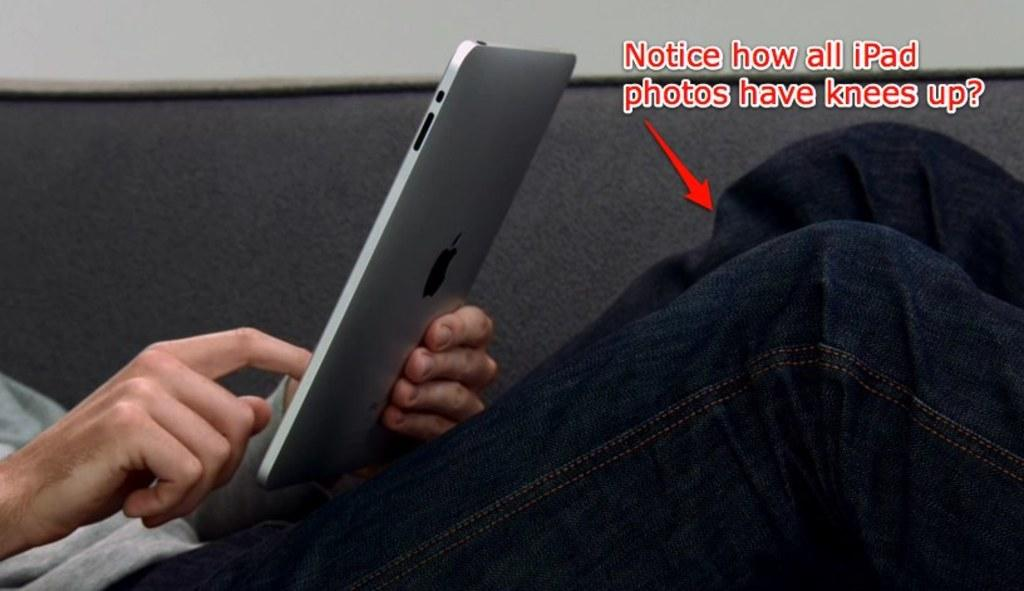What is the person in the image holding? The person is holding an iPad in the image. What can be seen on the iPad? There is writing on the image, which suggests that the person might be reading or writing something on the iPad. What is visible in the background of the image? There is a wall in the background of the image. What type of wool is the person wearing in the image? There is no wool visible in the image, as the person is holding an iPad and not wearing any clothing. 